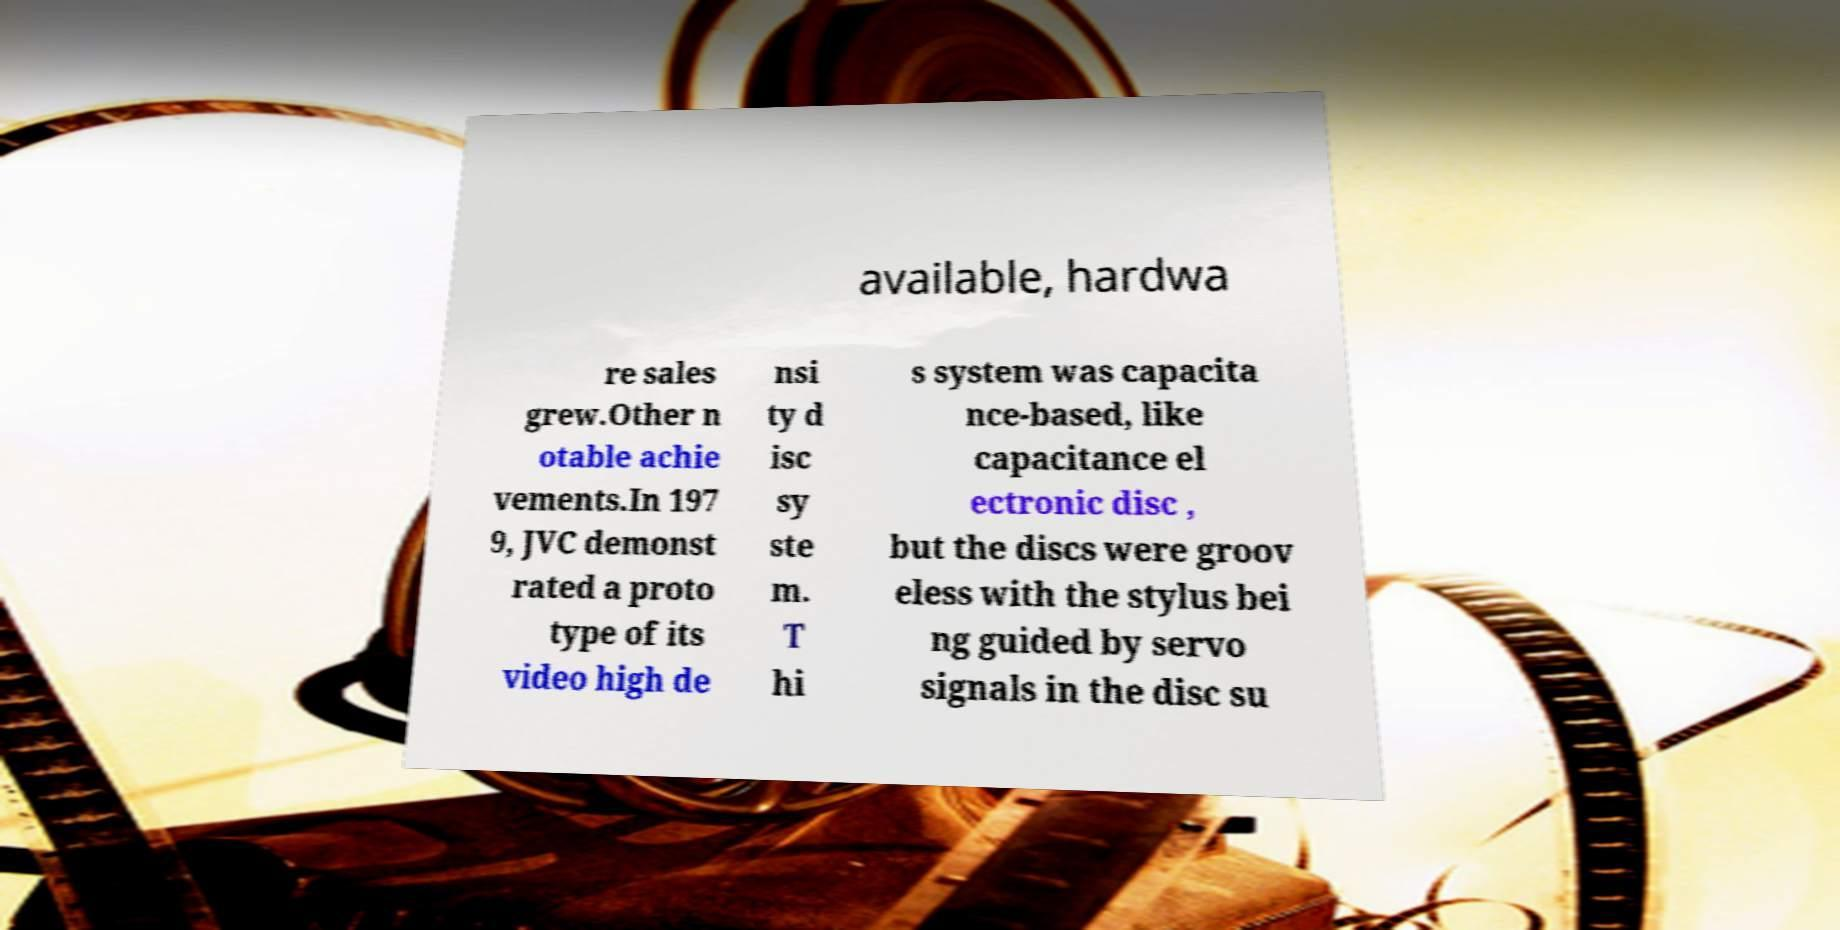Could you assist in decoding the text presented in this image and type it out clearly? available, hardwa re sales grew.Other n otable achie vements.In 197 9, JVC demonst rated a proto type of its video high de nsi ty d isc sy ste m. T hi s system was capacita nce-based, like capacitance el ectronic disc , but the discs were groov eless with the stylus bei ng guided by servo signals in the disc su 